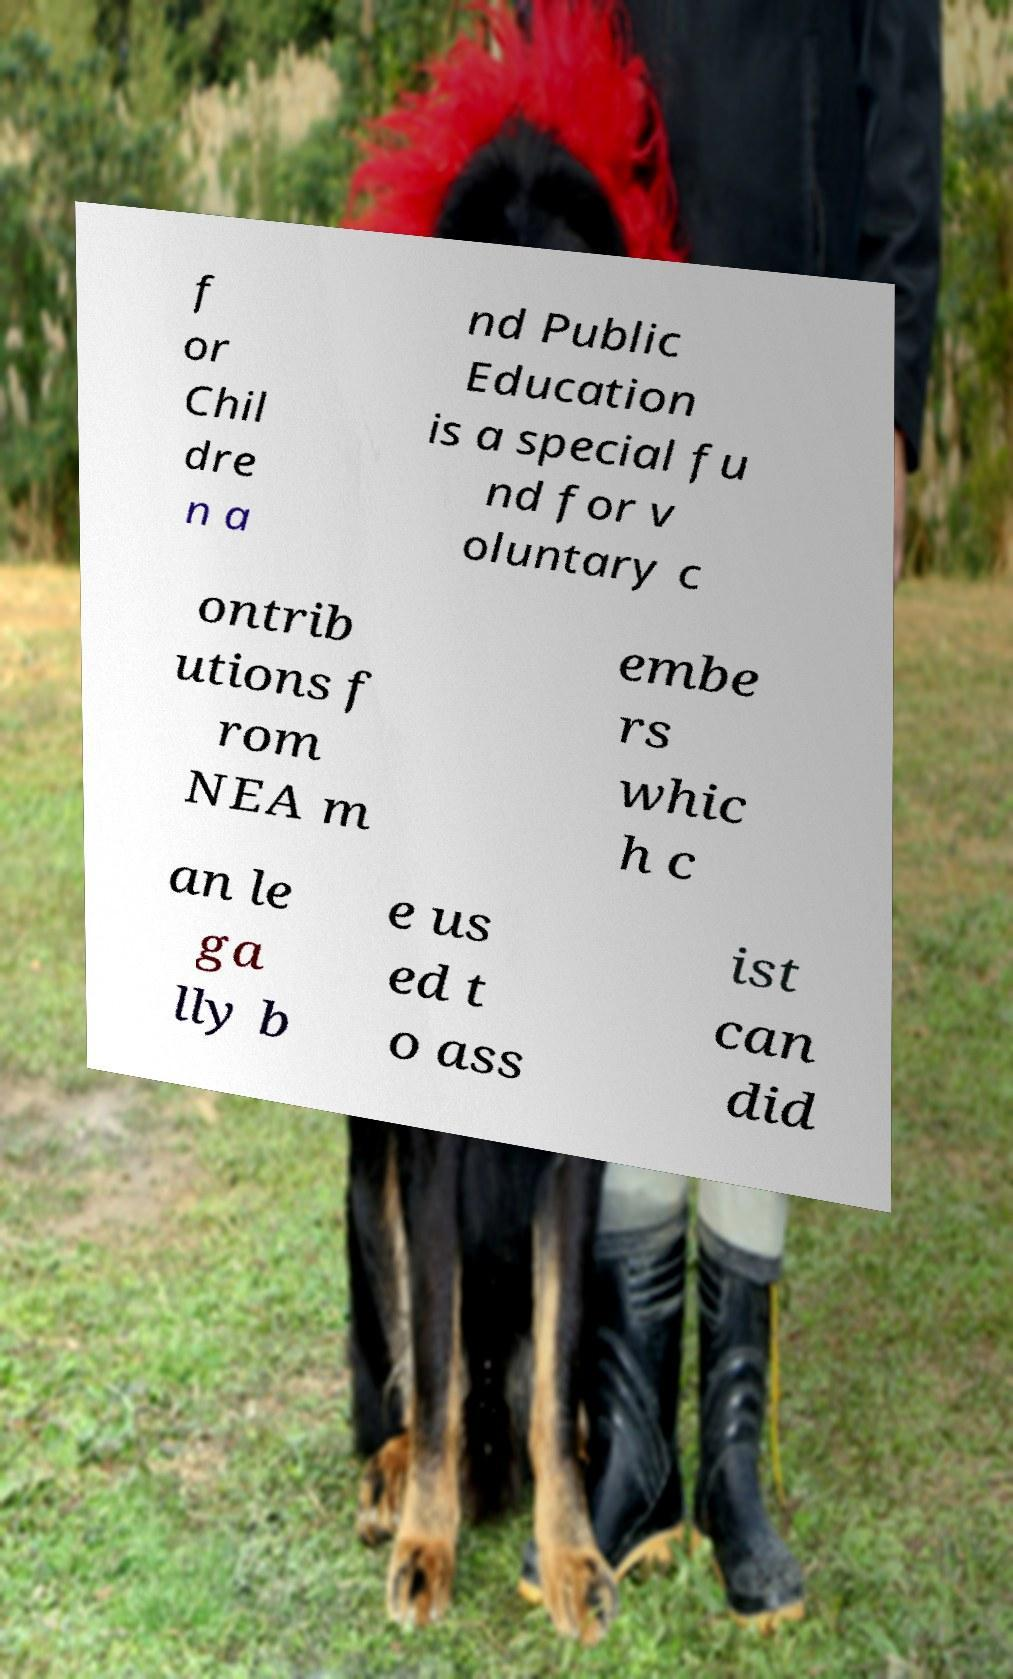There's text embedded in this image that I need extracted. Can you transcribe it verbatim? f or Chil dre n a nd Public Education is a special fu nd for v oluntary c ontrib utions f rom NEA m embe rs whic h c an le ga lly b e us ed t o ass ist can did 